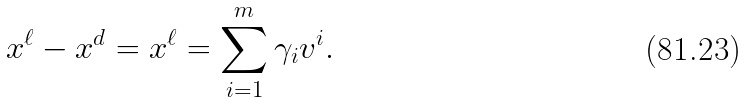Convert formula to latex. <formula><loc_0><loc_0><loc_500><loc_500>x ^ { \ell } - x ^ { d } = x ^ { \ell } = \sum _ { i = 1 } ^ { m } \gamma _ { i } v ^ { i } .</formula> 